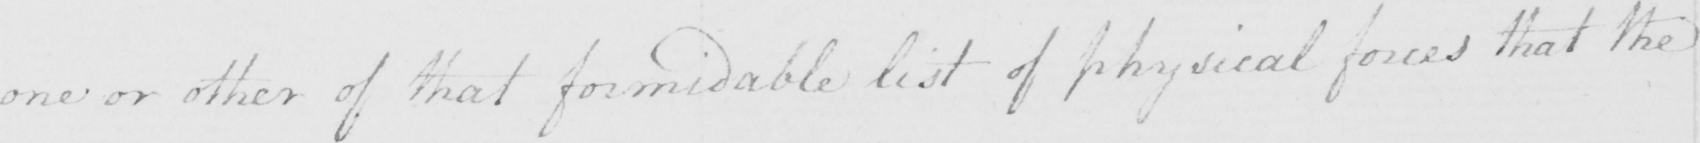What is written in this line of handwriting? one or other of that formidable list of physical forces that the 